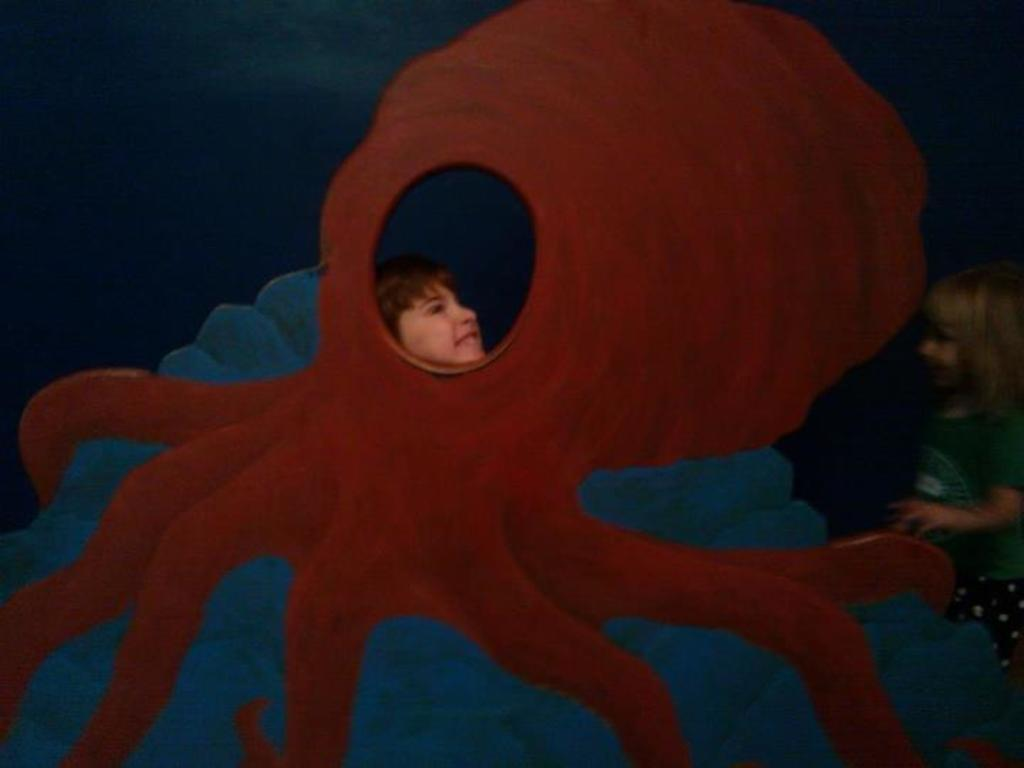What is the main object in the image? There is a frame in the image. Who or what is inside the frame? There are two children in the image. What type of humor can be seen in the line drawn by the children in the image? There is no line drawn by the children in the image, nor is there any humor present. 